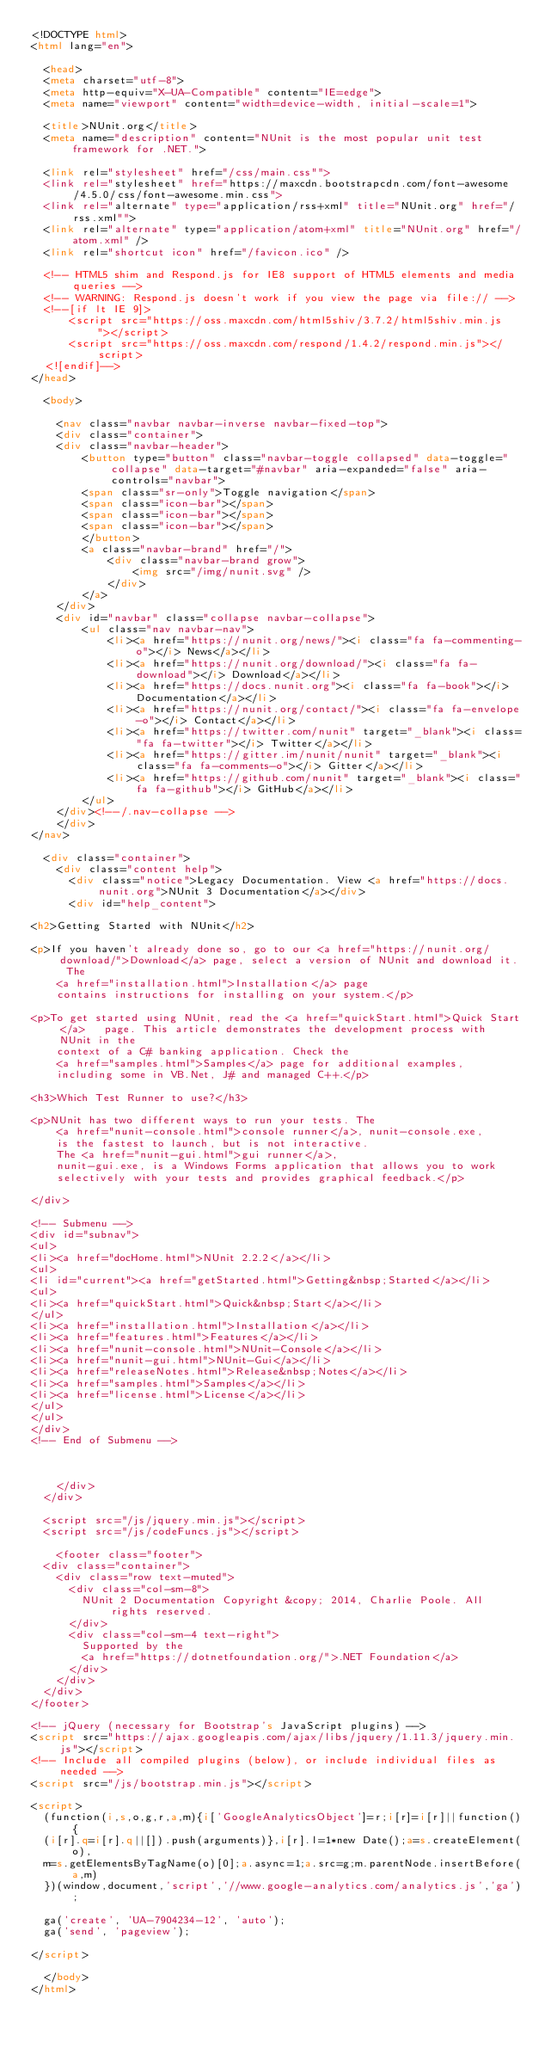<code> <loc_0><loc_0><loc_500><loc_500><_HTML_><!DOCTYPE html>
<html lang="en">

  <head>
  <meta charset="utf-8">
  <meta http-equiv="X-UA-Compatible" content="IE=edge">
  <meta name="viewport" content="width=device-width, initial-scale=1">

  <title>NUnit.org</title>
  <meta name="description" content="NUnit is the most popular unit test framework for .NET.">

  <link rel="stylesheet" href="/css/main.css"">
  <link rel="stylesheet" href="https://maxcdn.bootstrapcdn.com/font-awesome/4.5.0/css/font-awesome.min.css">
  <link rel="alternate" type="application/rss+xml" title="NUnit.org" href="/rss.xml"">
  <link rel="alternate" type="application/atom+xml" title="NUnit.org" href="/atom.xml" />
  <link rel="shortcut icon" href="/favicon.ico" />

  <!-- HTML5 shim and Respond.js for IE8 support of HTML5 elements and media queries -->
  <!-- WARNING: Respond.js doesn't work if you view the page via file:// -->
  <!--[if lt IE 9]>
      <script src="https://oss.maxcdn.com/html5shiv/3.7.2/html5shiv.min.js"></script>
      <script src="https://oss.maxcdn.com/respond/1.4.2/respond.min.js"></script>
  <![endif]-->
</head>

  <body>

    <nav class="navbar navbar-inverse navbar-fixed-top">
    <div class="container">
    <div class="navbar-header">
        <button type="button" class="navbar-toggle collapsed" data-toggle="collapse" data-target="#navbar" aria-expanded="false" aria-controls="navbar">
        <span class="sr-only">Toggle navigation</span>
        <span class="icon-bar"></span>
        <span class="icon-bar"></span>
        <span class="icon-bar"></span>
        </button>
        <a class="navbar-brand" href="/">
            <div class="navbar-brand grow">
                <img src="/img/nunit.svg" />
            </div>
        </a>
    </div>
    <div id="navbar" class="collapse navbar-collapse">
        <ul class="nav navbar-nav">
            <li><a href="https://nunit.org/news/"><i class="fa fa-commenting-o"></i> News</a></li>
            <li><a href="https://nunit.org/download/"><i class="fa fa-download"></i> Download</a></li>
            <li><a href="https://docs.nunit.org"><i class="fa fa-book"></i> Documentation</a></li>
            <li><a href="https://nunit.org/contact/"><i class="fa fa-envelope-o"></i> Contact</a></li>
            <li><a href="https://twitter.com/nunit" target="_blank"><i class="fa fa-twitter"></i> Twitter</a></li>
            <li><a href="https://gitter.im/nunit/nunit" target="_blank"><i class="fa fa-comments-o"></i> Gitter</a></li>
            <li><a href="https://github.com/nunit" target="_blank"><i class="fa fa-github"></i> GitHub</a></li>
        </ul>
    </div><!--/.nav-collapse -->
    </div>
</nav>

  <div class="container">
    <div class="content help">
      <div class="notice">Legacy Documentation. View <a href="https://docs.nunit.org">NUnit 3 Documentation</a></div>
      <div id="help_content">

<h2>Getting Started with NUnit</h2>

<p>If you haven't already done so, go to our <a href="https://nunit.org/download/">Download</a>	page, select a version of NUnit and download it. The 
	<a href="installation.html">Installation</a> page 
	contains instructions for installing on your system.</p>

<p>To get started using NUnit, read the <a href="quickStart.html">Quick Start</a>	page. This article demonstrates the development process with NUnit in the 
	context of a C# banking application. Check the 
	<a href="samples.html">Samples</a> page for additional examples, 
	including some in VB.Net, J# and managed C++.</p>

<h3>Which Test Runner to use?</h3>

<p>NUnit has two different ways to run your tests. The 
	<a href="nunit-console.html">console runner</a>, nunit-console.exe, 
	is the fastest to launch, but is not interactive. 
 	The <a href="nunit-gui.html">gui runner</a>, 
	nunit-gui.exe, is a Windows Forms application that allows you to work 
	selectively with your tests and provides graphical feedback.</p>

</div>

<!-- Submenu -->
<div id="subnav">
<ul>
<li><a href="docHome.html">NUnit 2.2.2</a></li>
<ul>
<li id="current"><a href="getStarted.html">Getting&nbsp;Started</a></li>
<ul>
<li><a href="quickStart.html">Quick&nbsp;Start</a></li>
</ul>
<li><a href="installation.html">Installation</a></li>
<li><a href="features.html">Features</a></li>
<li><a href="nunit-console.html">NUnit-Console</a></li>
<li><a href="nunit-gui.html">NUnit-Gui</a></li>
<li><a href="releaseNotes.html">Release&nbsp;Notes</a></li>
<li><a href="samples.html">Samples</a></li>
<li><a href="license.html">License</a></li>
</ul>
</ul>
</div>
<!-- End of Submenu -->



    </div>
  </div>

  <script src="/js/jquery.min.js"></script>
  <script src="/js/codeFuncs.js"></script>

    <footer class="footer">
  <div class="container">
    <div class="row text-muted">
      <div class="col-sm-8">
        NUnit 2 Documentation Copyright &copy; 2014, Charlie Poole. All rights reserved.
      </div>
      <div class="col-sm-4 text-right">
        Supported by the
        <a href="https://dotnetfoundation.org/">.NET Foundation</a>
      </div>
    </div>
  </div>
</footer>

<!-- jQuery (necessary for Bootstrap's JavaScript plugins) -->
<script src="https://ajax.googleapis.com/ajax/libs/jquery/1.11.3/jquery.min.js"></script>
<!-- Include all compiled plugins (below), or include individual files as needed -->
<script src="/js/bootstrap.min.js"></script>

<script>
  (function(i,s,o,g,r,a,m){i['GoogleAnalyticsObject']=r;i[r]=i[r]||function(){
  (i[r].q=i[r].q||[]).push(arguments)},i[r].l=1*new Date();a=s.createElement(o),
  m=s.getElementsByTagName(o)[0];a.async=1;a.src=g;m.parentNode.insertBefore(a,m)
  })(window,document,'script','//www.google-analytics.com/analytics.js','ga');

  ga('create', 'UA-7904234-12', 'auto');
  ga('send', 'pageview');

</script>

  </body>
</html>
</code> 